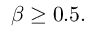<formula> <loc_0><loc_0><loc_500><loc_500>\beta \geq 0 . 5 .</formula> 